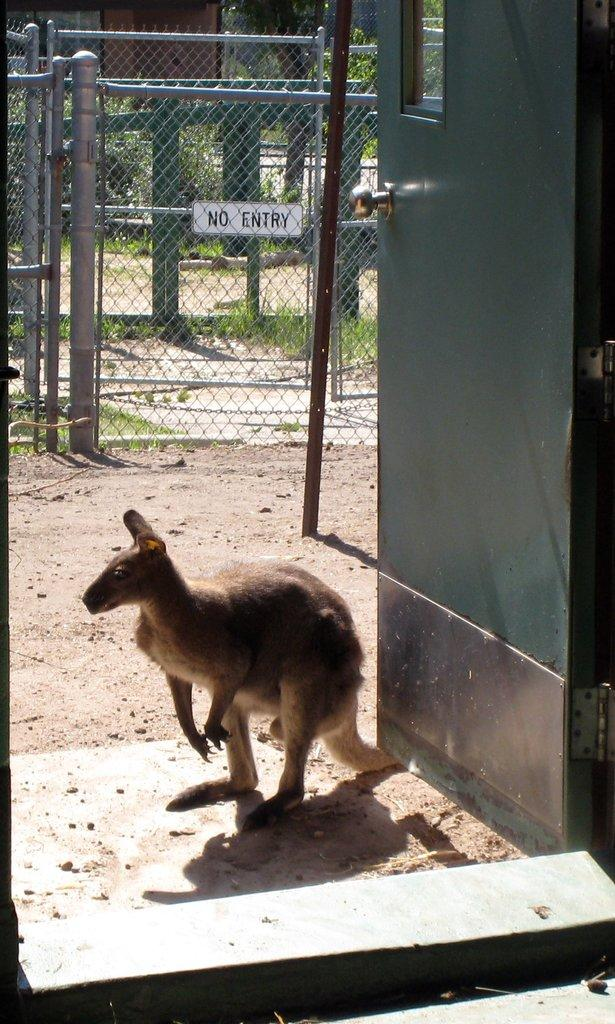What animal is present in the image? There is a kangaroo in the image. Where is the kangaroo located in relation to the door? The kangaroo is visible in front of a door. On which side of the image is the door located? The door is visible on the right side of the image. What is in the middle of the image? There is a fence in the middle of the image. What can be seen through the fence? Trees are visible through the fence. What type of bone can be seen in the kangaroo's pouch in the image? There is no bone visible in the kangaroo's pouch in the image. What song is the kangaroo singing in the image? The kangaroo is not singing in the image, and there is no mention of a song. 